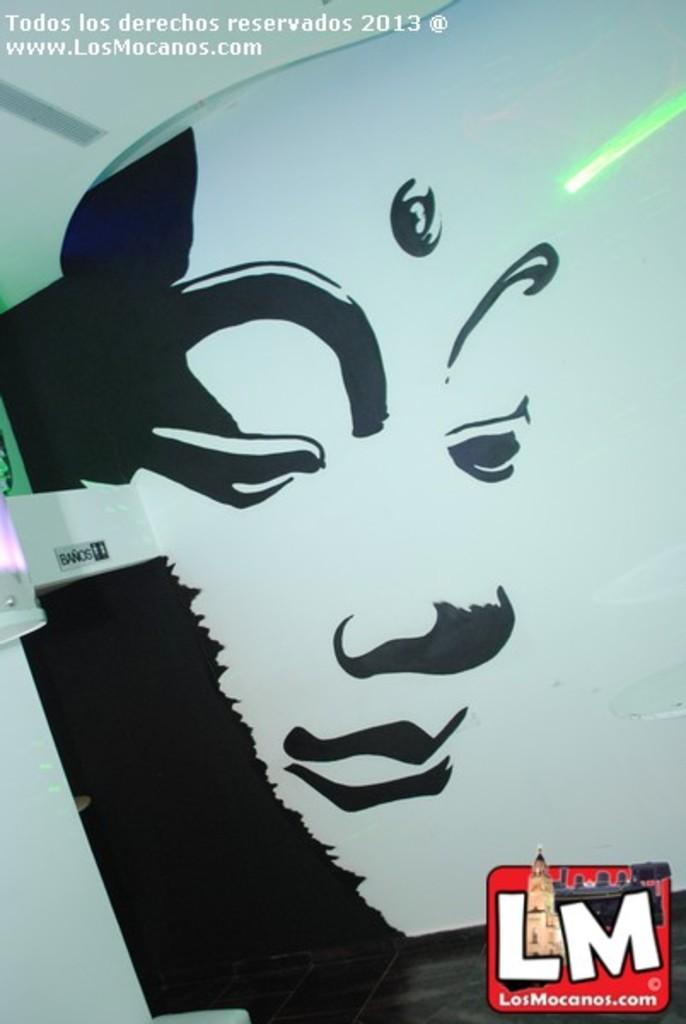What is depicted on the wall in the image? There is a sketch on the wall in the image. What authority does the sketch have in the image? The sketch does not have any authority in the image, as it is a static representation on the wall. 